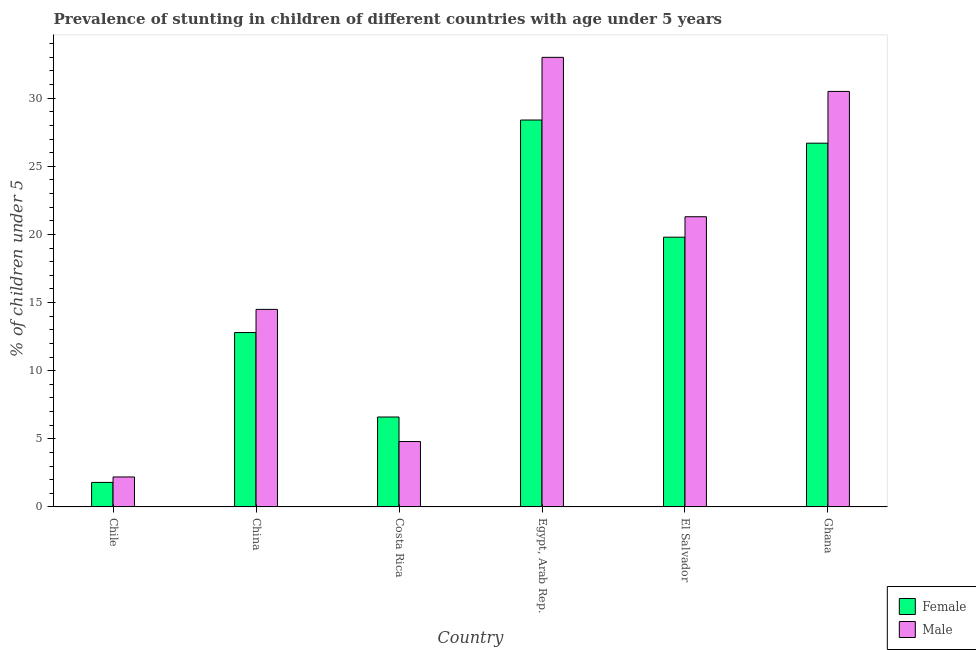How many different coloured bars are there?
Offer a very short reply. 2. Are the number of bars per tick equal to the number of legend labels?
Give a very brief answer. Yes. How many bars are there on the 4th tick from the left?
Your response must be concise. 2. How many bars are there on the 1st tick from the right?
Keep it short and to the point. 2. What is the label of the 5th group of bars from the left?
Keep it short and to the point. El Salvador. What is the percentage of stunted female children in China?
Your answer should be very brief. 12.8. Across all countries, what is the maximum percentage of stunted male children?
Your response must be concise. 33. Across all countries, what is the minimum percentage of stunted female children?
Provide a short and direct response. 1.8. In which country was the percentage of stunted male children maximum?
Your response must be concise. Egypt, Arab Rep. What is the total percentage of stunted male children in the graph?
Make the answer very short. 106.3. What is the difference between the percentage of stunted male children in Costa Rica and that in Egypt, Arab Rep.?
Keep it short and to the point. -28.2. What is the difference between the percentage of stunted female children in Ghana and the percentage of stunted male children in Egypt, Arab Rep.?
Your answer should be very brief. -6.3. What is the average percentage of stunted male children per country?
Your answer should be very brief. 17.72. What is the difference between the percentage of stunted female children and percentage of stunted male children in China?
Your answer should be very brief. -1.7. In how many countries, is the percentage of stunted female children greater than 32 %?
Offer a very short reply. 0. What is the ratio of the percentage of stunted male children in Chile to that in El Salvador?
Keep it short and to the point. 0.1. What is the difference between the highest and the lowest percentage of stunted male children?
Ensure brevity in your answer.  30.8. In how many countries, is the percentage of stunted male children greater than the average percentage of stunted male children taken over all countries?
Keep it short and to the point. 3. Is the sum of the percentage of stunted female children in Costa Rica and Egypt, Arab Rep. greater than the maximum percentage of stunted male children across all countries?
Offer a very short reply. Yes. What does the 2nd bar from the right in El Salvador represents?
Ensure brevity in your answer.  Female. How many bars are there?
Ensure brevity in your answer.  12. How many countries are there in the graph?
Provide a short and direct response. 6. Does the graph contain any zero values?
Offer a terse response. No. How are the legend labels stacked?
Make the answer very short. Vertical. What is the title of the graph?
Offer a terse response. Prevalence of stunting in children of different countries with age under 5 years. Does "Agricultural land" appear as one of the legend labels in the graph?
Your response must be concise. No. What is the label or title of the Y-axis?
Your response must be concise.  % of children under 5. What is the  % of children under 5 of Female in Chile?
Provide a succinct answer. 1.8. What is the  % of children under 5 in Male in Chile?
Keep it short and to the point. 2.2. What is the  % of children under 5 in Female in China?
Provide a short and direct response. 12.8. What is the  % of children under 5 in Male in China?
Your response must be concise. 14.5. What is the  % of children under 5 in Female in Costa Rica?
Your answer should be very brief. 6.6. What is the  % of children under 5 of Male in Costa Rica?
Provide a succinct answer. 4.8. What is the  % of children under 5 in Female in Egypt, Arab Rep.?
Your answer should be compact. 28.4. What is the  % of children under 5 in Female in El Salvador?
Give a very brief answer. 19.8. What is the  % of children under 5 in Male in El Salvador?
Your response must be concise. 21.3. What is the  % of children under 5 in Female in Ghana?
Keep it short and to the point. 26.7. What is the  % of children under 5 in Male in Ghana?
Offer a very short reply. 30.5. Across all countries, what is the maximum  % of children under 5 in Female?
Provide a succinct answer. 28.4. Across all countries, what is the minimum  % of children under 5 of Female?
Your response must be concise. 1.8. Across all countries, what is the minimum  % of children under 5 of Male?
Your answer should be very brief. 2.2. What is the total  % of children under 5 of Female in the graph?
Make the answer very short. 96.1. What is the total  % of children under 5 in Male in the graph?
Keep it short and to the point. 106.3. What is the difference between the  % of children under 5 in Male in Chile and that in Costa Rica?
Your response must be concise. -2.6. What is the difference between the  % of children under 5 in Female in Chile and that in Egypt, Arab Rep.?
Offer a very short reply. -26.6. What is the difference between the  % of children under 5 in Male in Chile and that in Egypt, Arab Rep.?
Your response must be concise. -30.8. What is the difference between the  % of children under 5 in Male in Chile and that in El Salvador?
Your answer should be compact. -19.1. What is the difference between the  % of children under 5 of Female in Chile and that in Ghana?
Offer a very short reply. -24.9. What is the difference between the  % of children under 5 of Male in Chile and that in Ghana?
Your response must be concise. -28.3. What is the difference between the  % of children under 5 in Female in China and that in Costa Rica?
Your answer should be very brief. 6.2. What is the difference between the  % of children under 5 in Female in China and that in Egypt, Arab Rep.?
Provide a short and direct response. -15.6. What is the difference between the  % of children under 5 in Male in China and that in Egypt, Arab Rep.?
Your response must be concise. -18.5. What is the difference between the  % of children under 5 in Male in China and that in El Salvador?
Offer a very short reply. -6.8. What is the difference between the  % of children under 5 of Female in China and that in Ghana?
Make the answer very short. -13.9. What is the difference between the  % of children under 5 in Male in China and that in Ghana?
Offer a very short reply. -16. What is the difference between the  % of children under 5 of Female in Costa Rica and that in Egypt, Arab Rep.?
Give a very brief answer. -21.8. What is the difference between the  % of children under 5 in Male in Costa Rica and that in Egypt, Arab Rep.?
Your response must be concise. -28.2. What is the difference between the  % of children under 5 of Female in Costa Rica and that in El Salvador?
Ensure brevity in your answer.  -13.2. What is the difference between the  % of children under 5 in Male in Costa Rica and that in El Salvador?
Offer a very short reply. -16.5. What is the difference between the  % of children under 5 in Female in Costa Rica and that in Ghana?
Your response must be concise. -20.1. What is the difference between the  % of children under 5 in Male in Costa Rica and that in Ghana?
Your answer should be very brief. -25.7. What is the difference between the  % of children under 5 in Female in Egypt, Arab Rep. and that in El Salvador?
Your answer should be compact. 8.6. What is the difference between the  % of children under 5 of Male in Egypt, Arab Rep. and that in El Salvador?
Make the answer very short. 11.7. What is the difference between the  % of children under 5 of Female in Egypt, Arab Rep. and that in Ghana?
Offer a terse response. 1.7. What is the difference between the  % of children under 5 in Female in El Salvador and that in Ghana?
Provide a succinct answer. -6.9. What is the difference between the  % of children under 5 in Female in Chile and the  % of children under 5 in Male in Egypt, Arab Rep.?
Your answer should be very brief. -31.2. What is the difference between the  % of children under 5 in Female in Chile and the  % of children under 5 in Male in El Salvador?
Offer a terse response. -19.5. What is the difference between the  % of children under 5 of Female in Chile and the  % of children under 5 of Male in Ghana?
Give a very brief answer. -28.7. What is the difference between the  % of children under 5 in Female in China and the  % of children under 5 in Male in Costa Rica?
Ensure brevity in your answer.  8. What is the difference between the  % of children under 5 in Female in China and the  % of children under 5 in Male in Egypt, Arab Rep.?
Ensure brevity in your answer.  -20.2. What is the difference between the  % of children under 5 of Female in China and the  % of children under 5 of Male in El Salvador?
Offer a terse response. -8.5. What is the difference between the  % of children under 5 of Female in China and the  % of children under 5 of Male in Ghana?
Provide a short and direct response. -17.7. What is the difference between the  % of children under 5 of Female in Costa Rica and the  % of children under 5 of Male in Egypt, Arab Rep.?
Provide a short and direct response. -26.4. What is the difference between the  % of children under 5 of Female in Costa Rica and the  % of children under 5 of Male in El Salvador?
Your response must be concise. -14.7. What is the difference between the  % of children under 5 in Female in Costa Rica and the  % of children under 5 in Male in Ghana?
Your response must be concise. -23.9. What is the difference between the  % of children under 5 in Female in Egypt, Arab Rep. and the  % of children under 5 in Male in El Salvador?
Keep it short and to the point. 7.1. What is the difference between the  % of children under 5 of Female in El Salvador and the  % of children under 5 of Male in Ghana?
Provide a short and direct response. -10.7. What is the average  % of children under 5 in Female per country?
Your response must be concise. 16.02. What is the average  % of children under 5 of Male per country?
Provide a short and direct response. 17.72. What is the difference between the  % of children under 5 of Female and  % of children under 5 of Male in China?
Offer a terse response. -1.7. What is the difference between the  % of children under 5 in Female and  % of children under 5 in Male in Egypt, Arab Rep.?
Provide a short and direct response. -4.6. What is the ratio of the  % of children under 5 of Female in Chile to that in China?
Your answer should be compact. 0.14. What is the ratio of the  % of children under 5 in Male in Chile to that in China?
Provide a succinct answer. 0.15. What is the ratio of the  % of children under 5 in Female in Chile to that in Costa Rica?
Provide a succinct answer. 0.27. What is the ratio of the  % of children under 5 in Male in Chile to that in Costa Rica?
Provide a succinct answer. 0.46. What is the ratio of the  % of children under 5 in Female in Chile to that in Egypt, Arab Rep.?
Keep it short and to the point. 0.06. What is the ratio of the  % of children under 5 in Male in Chile to that in Egypt, Arab Rep.?
Offer a terse response. 0.07. What is the ratio of the  % of children under 5 of Female in Chile to that in El Salvador?
Provide a succinct answer. 0.09. What is the ratio of the  % of children under 5 in Male in Chile to that in El Salvador?
Offer a very short reply. 0.1. What is the ratio of the  % of children under 5 of Female in Chile to that in Ghana?
Give a very brief answer. 0.07. What is the ratio of the  % of children under 5 in Male in Chile to that in Ghana?
Provide a short and direct response. 0.07. What is the ratio of the  % of children under 5 in Female in China to that in Costa Rica?
Your response must be concise. 1.94. What is the ratio of the  % of children under 5 in Male in China to that in Costa Rica?
Provide a short and direct response. 3.02. What is the ratio of the  % of children under 5 in Female in China to that in Egypt, Arab Rep.?
Provide a succinct answer. 0.45. What is the ratio of the  % of children under 5 of Male in China to that in Egypt, Arab Rep.?
Provide a succinct answer. 0.44. What is the ratio of the  % of children under 5 in Female in China to that in El Salvador?
Give a very brief answer. 0.65. What is the ratio of the  % of children under 5 in Male in China to that in El Salvador?
Offer a terse response. 0.68. What is the ratio of the  % of children under 5 in Female in China to that in Ghana?
Offer a terse response. 0.48. What is the ratio of the  % of children under 5 of Male in China to that in Ghana?
Give a very brief answer. 0.48. What is the ratio of the  % of children under 5 in Female in Costa Rica to that in Egypt, Arab Rep.?
Your answer should be compact. 0.23. What is the ratio of the  % of children under 5 in Male in Costa Rica to that in Egypt, Arab Rep.?
Keep it short and to the point. 0.15. What is the ratio of the  % of children under 5 of Female in Costa Rica to that in El Salvador?
Offer a terse response. 0.33. What is the ratio of the  % of children under 5 of Male in Costa Rica to that in El Salvador?
Your response must be concise. 0.23. What is the ratio of the  % of children under 5 of Female in Costa Rica to that in Ghana?
Provide a succinct answer. 0.25. What is the ratio of the  % of children under 5 in Male in Costa Rica to that in Ghana?
Make the answer very short. 0.16. What is the ratio of the  % of children under 5 in Female in Egypt, Arab Rep. to that in El Salvador?
Keep it short and to the point. 1.43. What is the ratio of the  % of children under 5 in Male in Egypt, Arab Rep. to that in El Salvador?
Offer a very short reply. 1.55. What is the ratio of the  % of children under 5 in Female in Egypt, Arab Rep. to that in Ghana?
Your answer should be compact. 1.06. What is the ratio of the  % of children under 5 of Male in Egypt, Arab Rep. to that in Ghana?
Offer a very short reply. 1.08. What is the ratio of the  % of children under 5 of Female in El Salvador to that in Ghana?
Your answer should be very brief. 0.74. What is the ratio of the  % of children under 5 of Male in El Salvador to that in Ghana?
Provide a succinct answer. 0.7. What is the difference between the highest and the second highest  % of children under 5 in Female?
Ensure brevity in your answer.  1.7. What is the difference between the highest and the lowest  % of children under 5 of Female?
Ensure brevity in your answer.  26.6. What is the difference between the highest and the lowest  % of children under 5 of Male?
Ensure brevity in your answer.  30.8. 